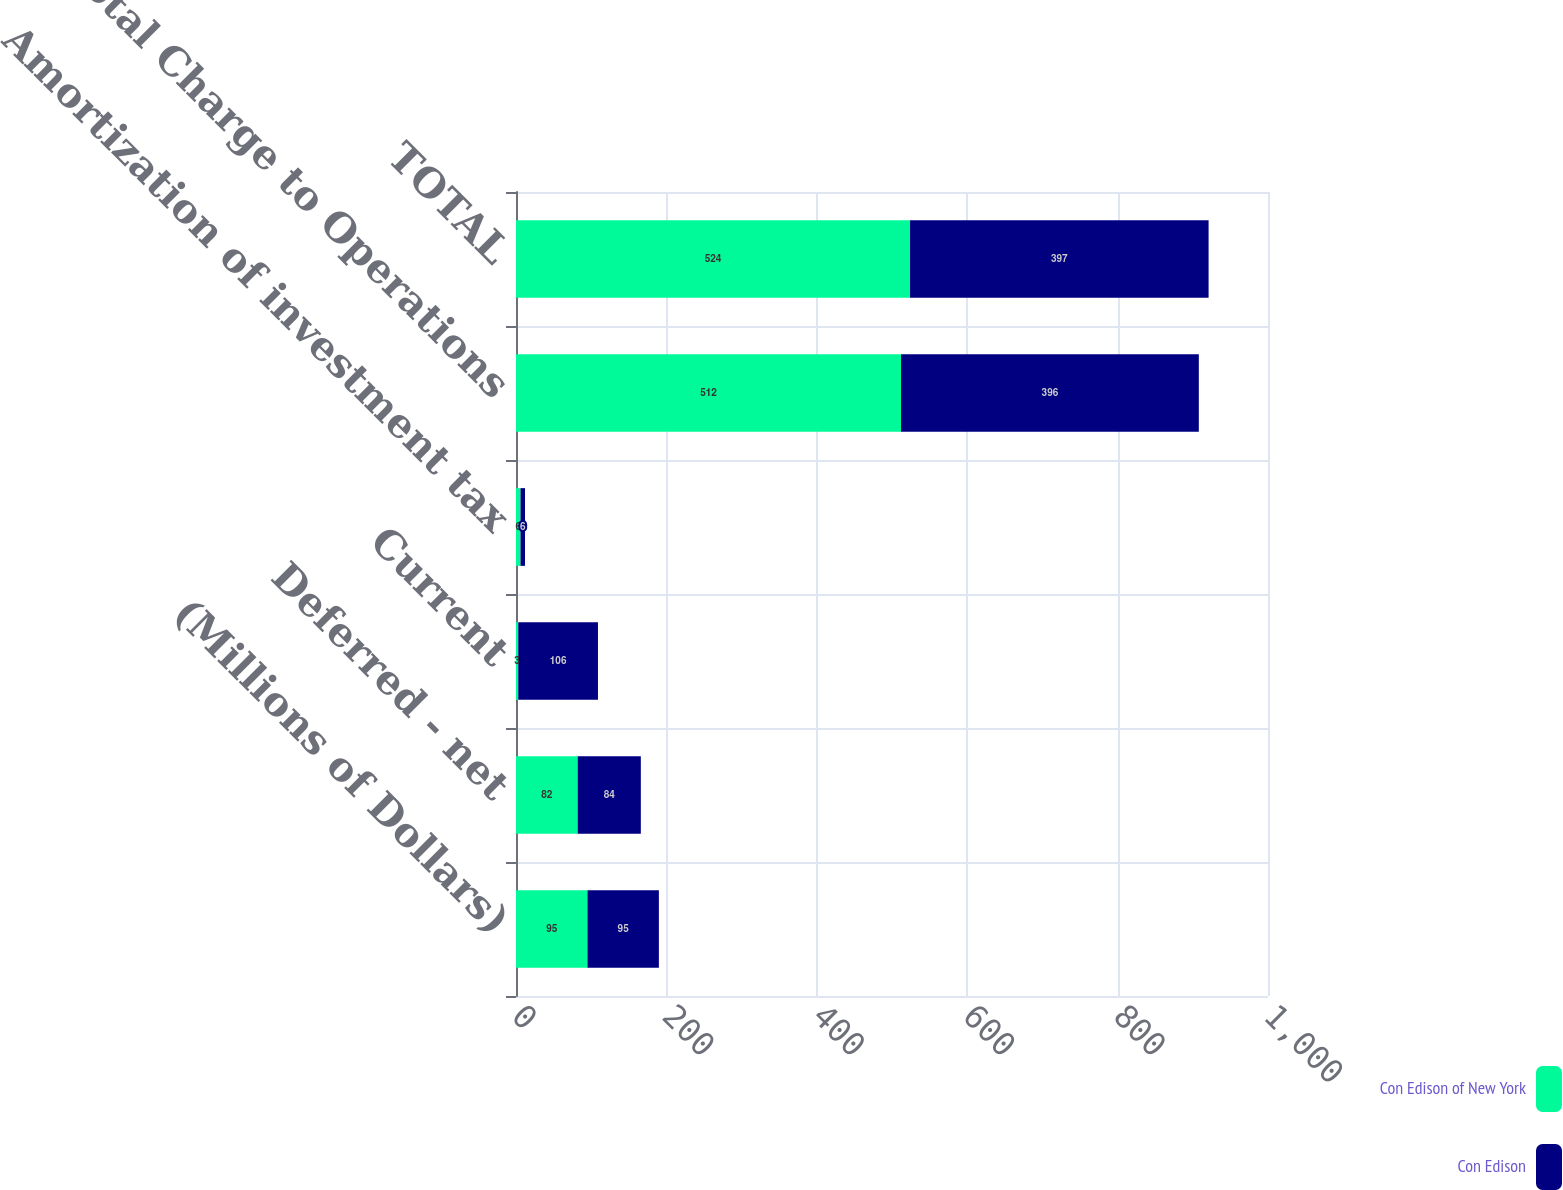Convert chart. <chart><loc_0><loc_0><loc_500><loc_500><stacked_bar_chart><ecel><fcel>(Millions of Dollars)<fcel>Deferred - net<fcel>Current<fcel>Amortization of investment tax<fcel>Total Charge to Operations<fcel>TOTAL<nl><fcel>Con Edison of New York<fcel>95<fcel>82<fcel>3<fcel>6<fcel>512<fcel>524<nl><fcel>Con Edison<fcel>95<fcel>84<fcel>106<fcel>6<fcel>396<fcel>397<nl></chart> 